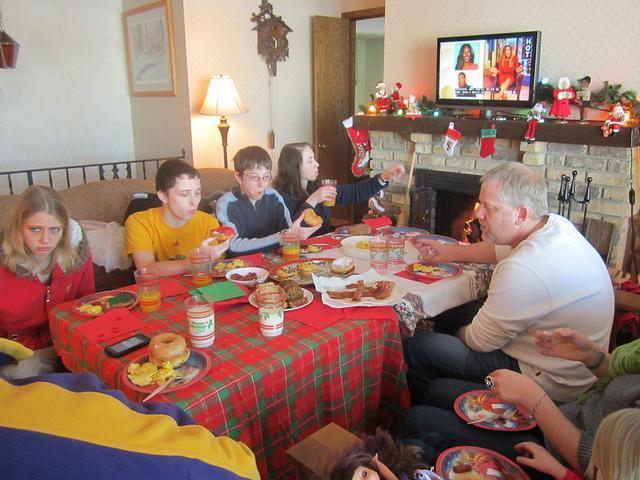How many people are there?
Give a very brief answer. 8. How many cars are in the road?
Give a very brief answer. 0. 